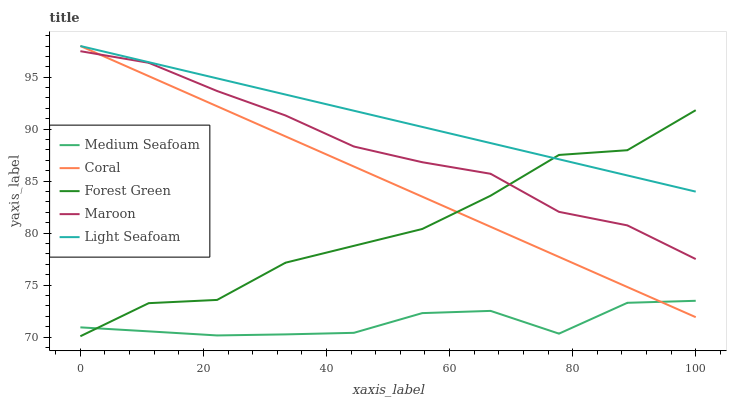Does Coral have the minimum area under the curve?
Answer yes or no. No. Does Coral have the maximum area under the curve?
Answer yes or no. No. Is Light Seafoam the smoothest?
Answer yes or no. No. Is Light Seafoam the roughest?
Answer yes or no. No. Does Coral have the lowest value?
Answer yes or no. No. Does Medium Seafoam have the highest value?
Answer yes or no. No. Is Medium Seafoam less than Light Seafoam?
Answer yes or no. Yes. Is Maroon greater than Medium Seafoam?
Answer yes or no. Yes. Does Medium Seafoam intersect Light Seafoam?
Answer yes or no. No. 